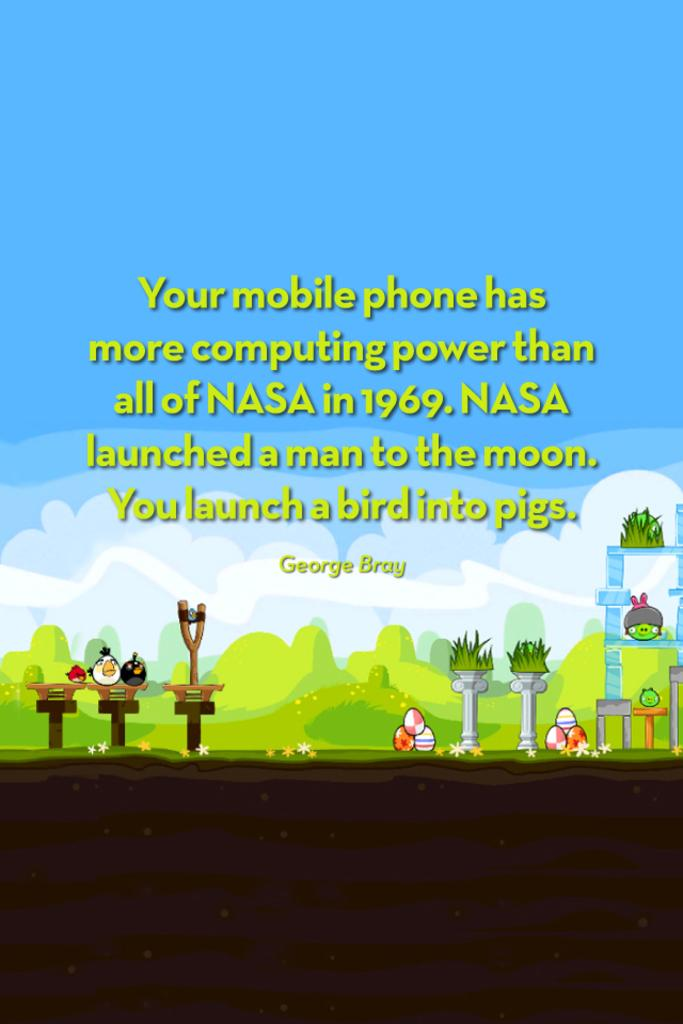<image>
Share a concise interpretation of the image provided. A George Bray quote says that a mobile phone is more powerful than all of NASA was in 1969. 